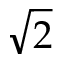<formula> <loc_0><loc_0><loc_500><loc_500>\sqrt { 2 }</formula> 